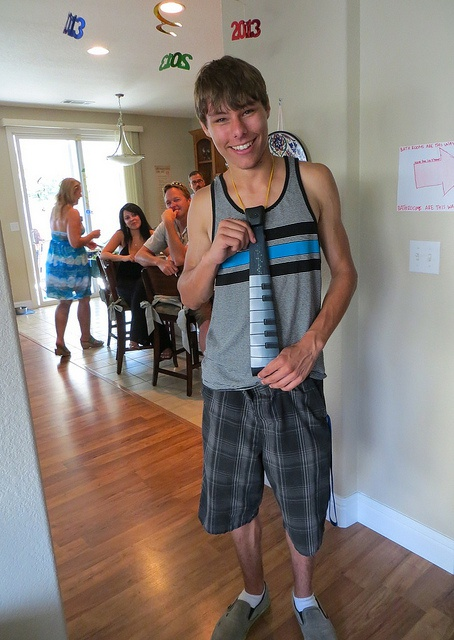Describe the objects in this image and their specific colors. I can see people in darkgray, black, gray, and brown tones, people in darkgray, gray, white, brown, and teal tones, chair in darkgray, black, and gray tones, tie in darkgray, black, lightblue, and blue tones, and chair in darkgray, black, white, and gray tones in this image. 